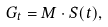Convert formula to latex. <formula><loc_0><loc_0><loc_500><loc_500>G _ { t } = M \cdot S ( t ) ,</formula> 